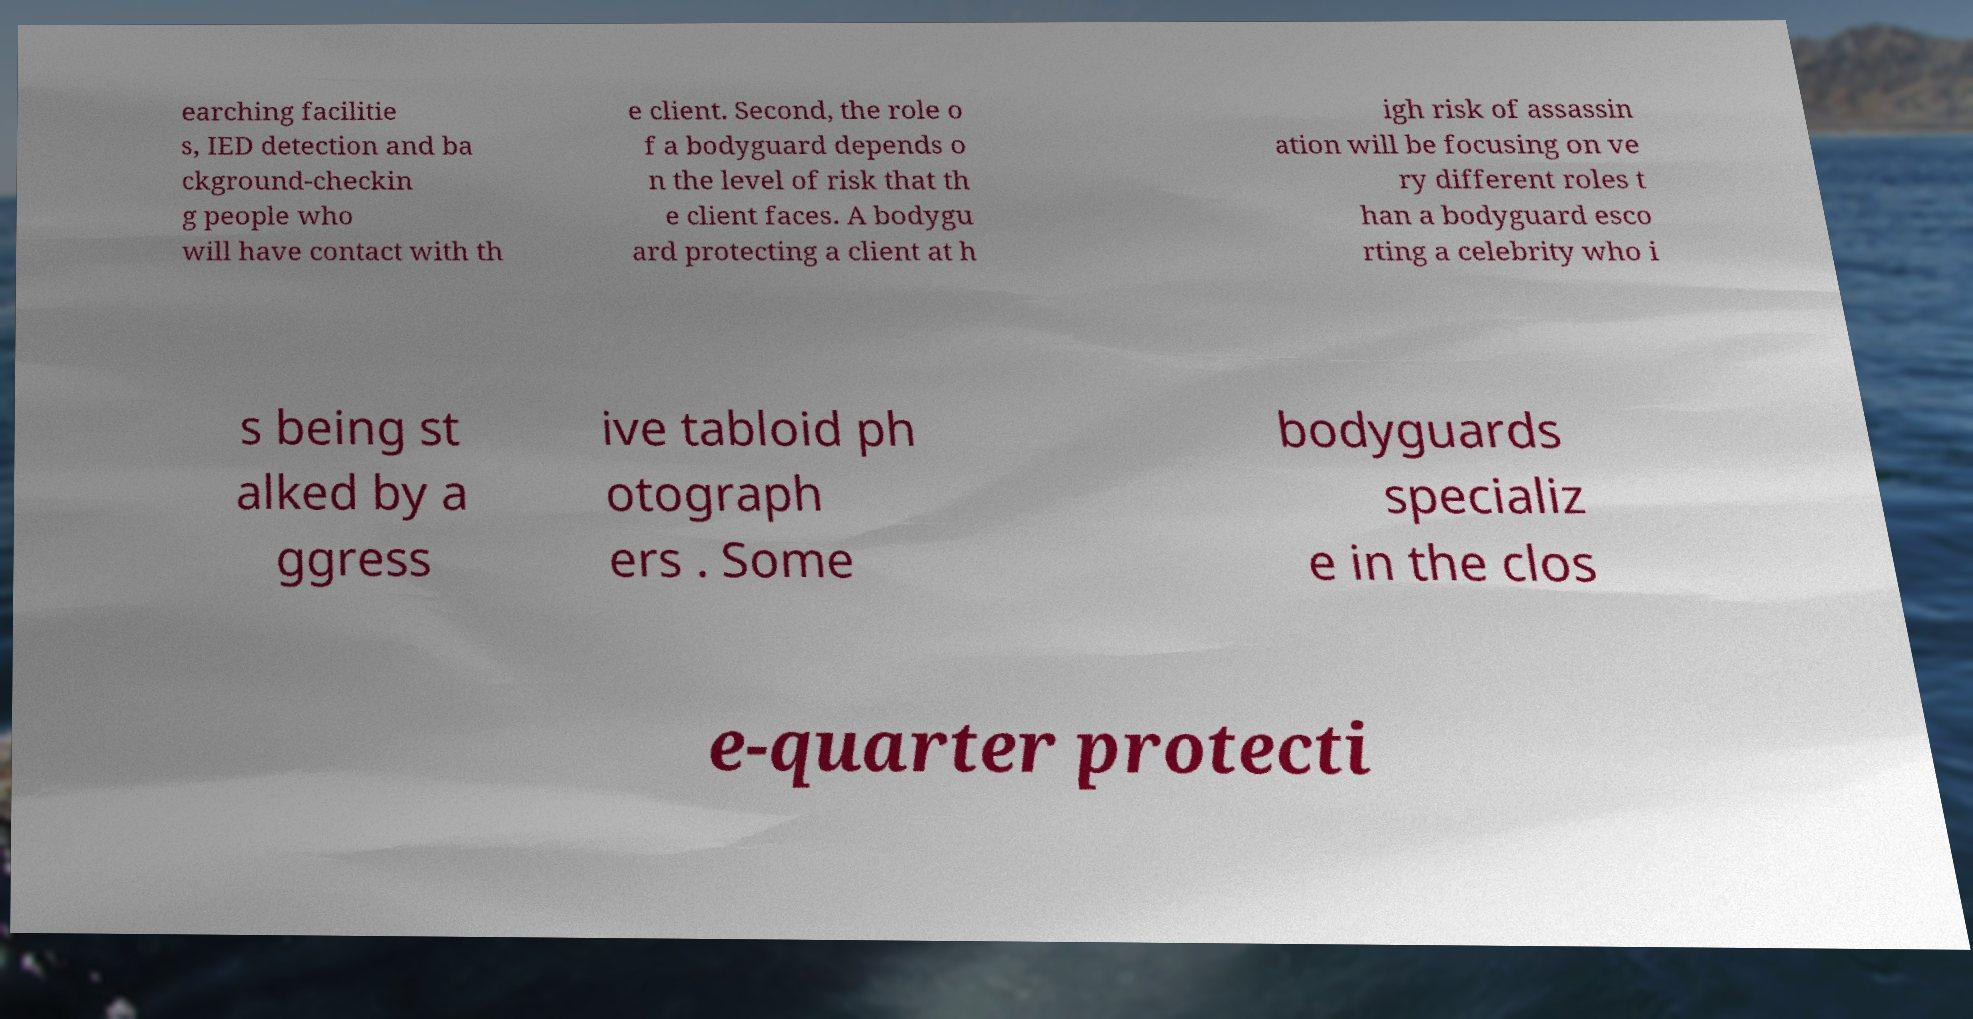Can you read and provide the text displayed in the image?This photo seems to have some interesting text. Can you extract and type it out for me? earching facilitie s, IED detection and ba ckground-checkin g people who will have contact with th e client. Second, the role o f a bodyguard depends o n the level of risk that th e client faces. A bodygu ard protecting a client at h igh risk of assassin ation will be focusing on ve ry different roles t han a bodyguard esco rting a celebrity who i s being st alked by a ggress ive tabloid ph otograph ers . Some bodyguards specializ e in the clos e-quarter protecti 